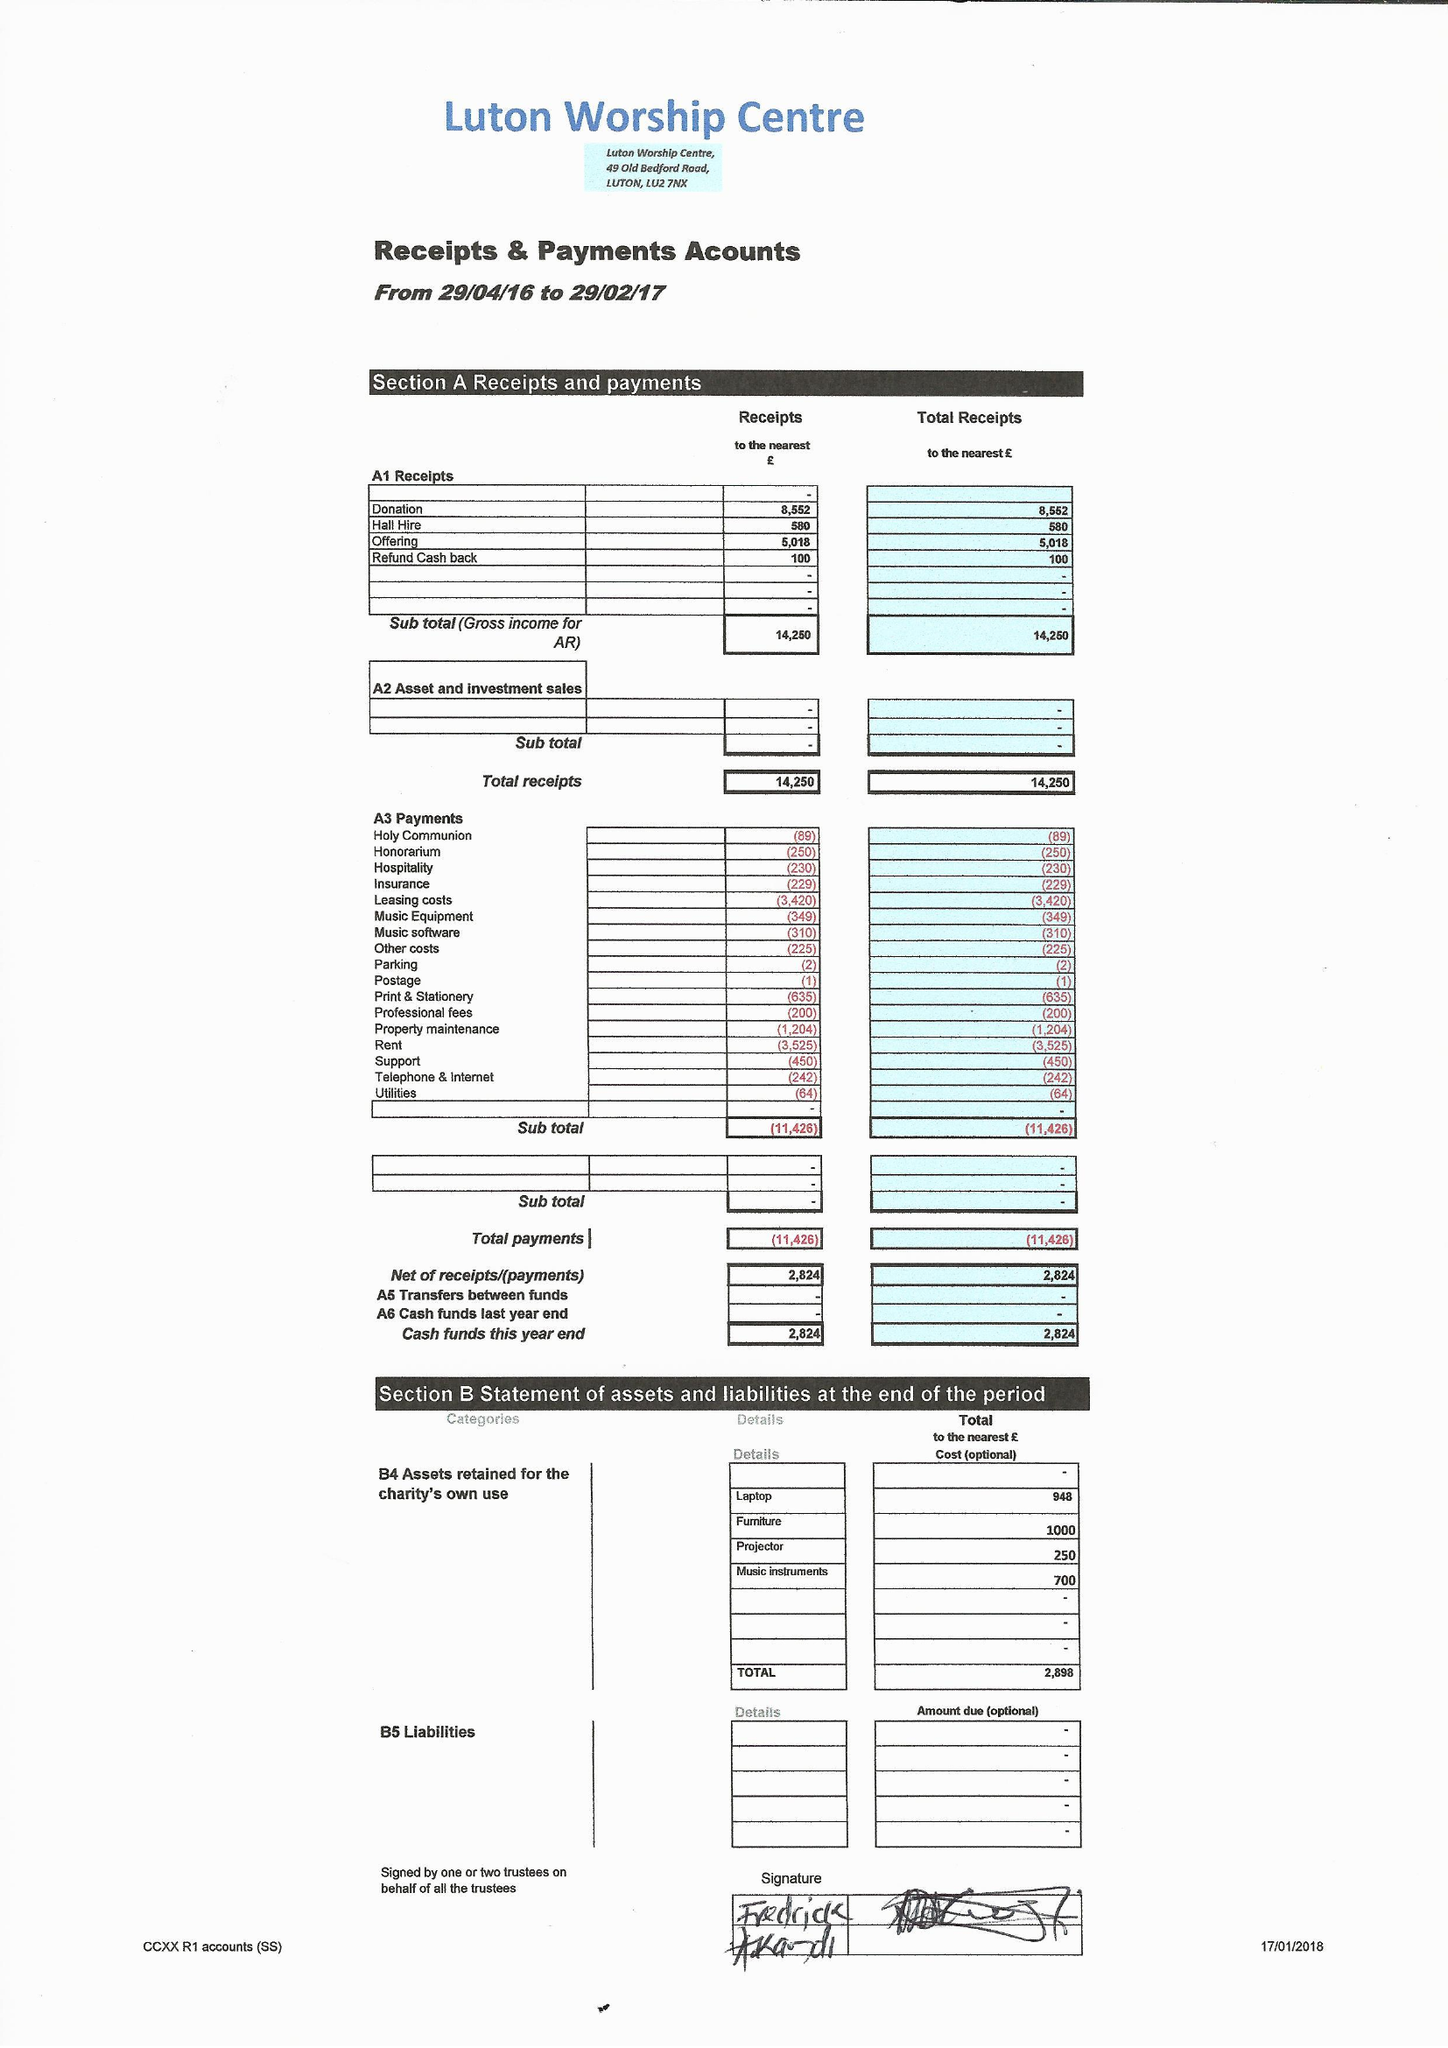What is the value for the address__street_line?
Answer the question using a single word or phrase. 49 OLD BEDFORD ROAD 